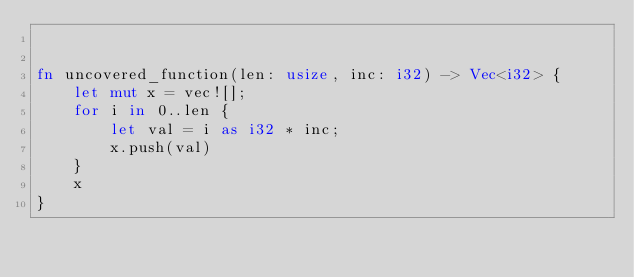Convert code to text. <code><loc_0><loc_0><loc_500><loc_500><_Rust_>

fn uncovered_function(len: usize, inc: i32) -> Vec<i32> {
    let mut x = vec![];
    for i in 0..len {
        let val = i as i32 * inc;
        x.push(val)
    }
    x
}
</code> 